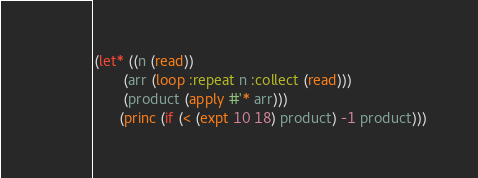<code> <loc_0><loc_0><loc_500><loc_500><_Lisp_>(let* ((n (read))
       (arr (loop :repeat n :collect (read)))
       (product (apply #'* arr)))
      (princ (if (< (expt 10 18) product) -1 product)))</code> 